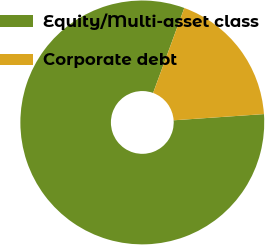Convert chart to OTSL. <chart><loc_0><loc_0><loc_500><loc_500><pie_chart><fcel>Equity/Multi-asset class<fcel>Corporate debt<nl><fcel>81.69%<fcel>18.31%<nl></chart> 